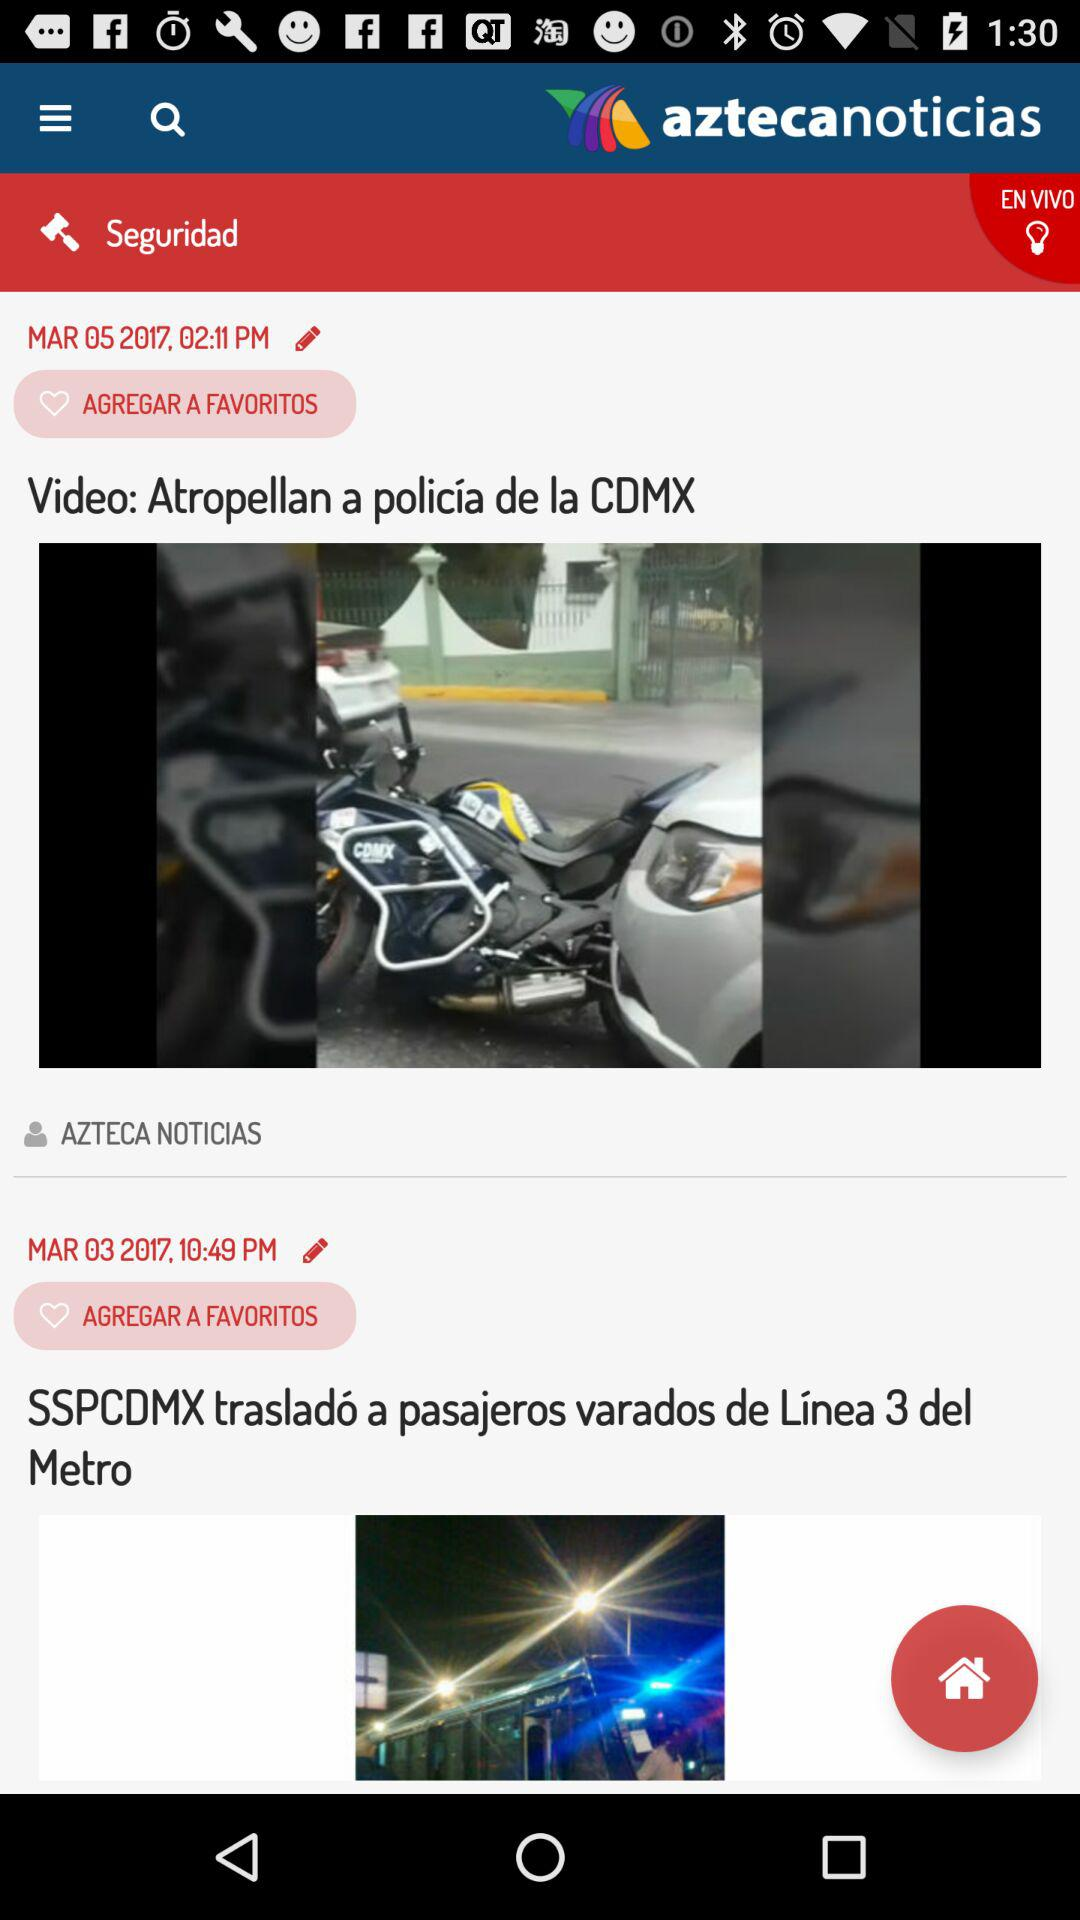How many videos are there in total?
Answer the question using a single word or phrase. 2 